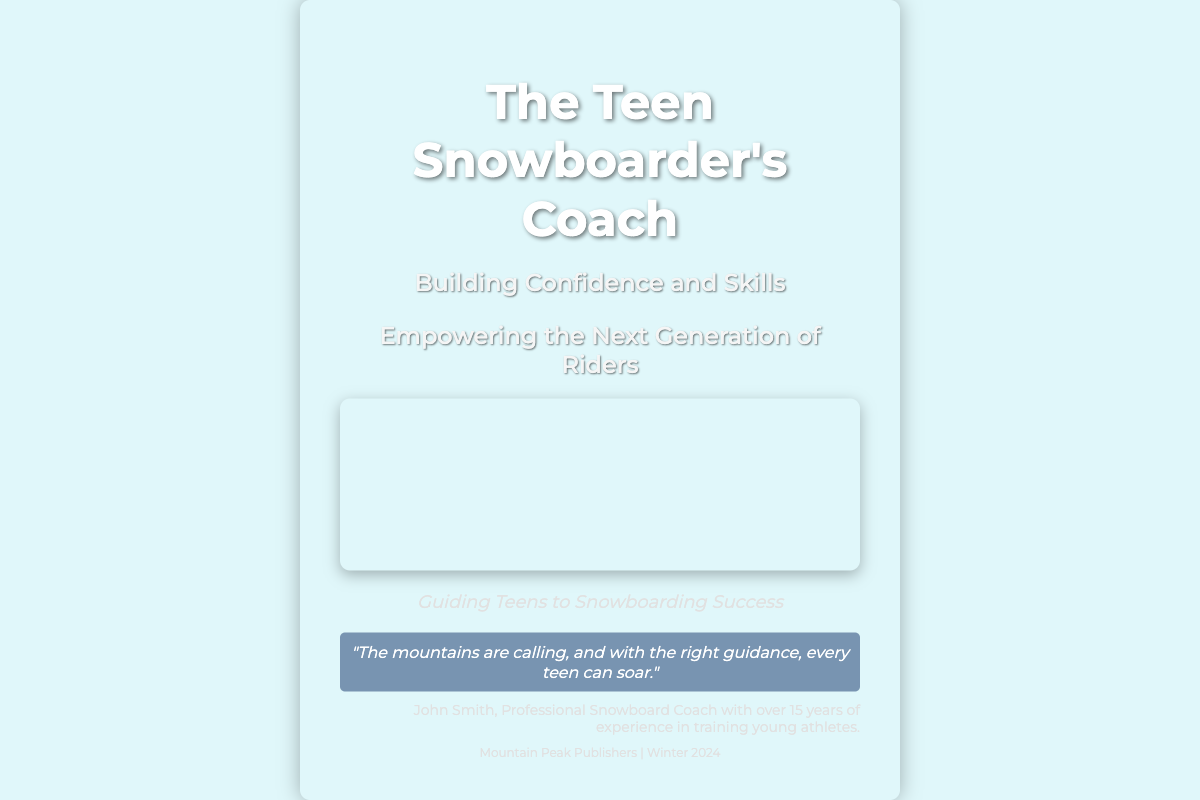What is the title of the book? The title is prominently displayed at the top of the cover, indicating the book's focus.
Answer: The Teen Snowboarder's Coach Who is the author of the book? The author information is given at the bottom of the cover.
Answer: John Smith What is the subtitle of the book? The subtitle appears below the title and gives insight into the book's content.
Answer: Building Confidence and Skills What does the quote on the cover imply? The quote reflects the motivational theme of the book and encourages teambuilding in snowboarding.
Answer: The mountains are calling, and with the right guidance, every teen can soar What publisher is associated with this book? This information is located at the bottom of the cover, specifying the publisher and the release period.
Answer: Mountain Peak Publishers How many years of experience does the author have? The author's experience is noted in his description, which highlights his qualifications.
Answer: 15 years What is one of the subtitles that speak to youth empowerment? The subtitle that emphasizes the target audience is featured prominently alongside the main title.
Answer: Empowering the Next Generation of Riders What season does the book aim to be published in? The publication season is stated on the cover, indicating when it will be available.
Answer: Winter 2024 What is the main visual theme of the cover? The imagery combines snowboarding and mentoring, visually conveying the book's subject matter.
Answer: Snowboarding and mentorship 